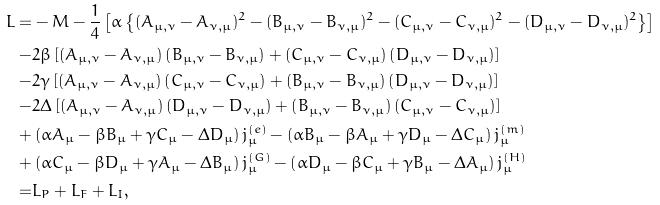<formula> <loc_0><loc_0><loc_500><loc_500>L = & - M - \frac { 1 } { 4 } \left [ \alpha \left \{ ( A _ { \mu , \nu } - A _ { \nu , \mu } ) ^ { 2 } - ( B _ { \mu , \nu } - B _ { \nu , \mu } ) ^ { 2 } - ( C _ { \mu , \nu } - C _ { \nu , \mu } ) ^ { 2 } - ( D _ { \mu , \nu } - D _ { \nu , \mu } ) ^ { 2 } \right \} \right ] \\ - & 2 \beta \left [ \left ( A _ { \mu , \nu } - A _ { \nu , \mu } \right ) \left ( B _ { \mu , \nu } - B _ { \nu , \mu } \right ) + \left ( C _ { \mu , \nu } - C _ { \nu , \mu } \right ) \left ( D _ { \mu , \nu } - D _ { \nu , \mu } \right ) \right ] \\ - & 2 \gamma \left [ \left ( A _ { \mu , \nu } - A _ { \nu , \mu } \right ) \left ( C _ { \mu , \nu } - C _ { \nu , \mu } \right ) + \left ( B _ { \mu , \nu } - B _ { \nu , \mu } \right ) \left ( D _ { \mu , \nu } - D _ { \nu , \mu } \right ) \right ] \\ - & 2 \Delta \left [ \left ( A _ { \mu , \nu } - A _ { \nu , \mu } \right ) \left ( D _ { \mu , \nu } - D _ { \nu , \mu } \right ) + \left ( B _ { \mu , \nu } - B _ { \nu , \mu } \right ) \left ( C _ { \mu , \nu } - C _ { \nu , \mu } \right ) \right ] \\ + & \left ( \alpha A _ { \mu } - \beta B _ { \mu } + \gamma C _ { \mu } - \Delta D _ { \mu } \right ) j _ { \mu } ^ { ( e ) } - \left ( \alpha B _ { \mu } - \beta A _ { \mu } + \gamma D _ { \mu } - \Delta C _ { \mu } \right ) j _ { \mu } ^ { ( m ) } \\ + & \left ( \alpha C _ { \mu } - \beta D _ { \mu } + \gamma A _ { \mu } - \Delta B _ { \mu } \right ) j _ { \mu } ^ { ( G ) } - \left ( \alpha D _ { \mu } - \beta C _ { \mu } + \gamma B _ { \mu } - \Delta A _ { \mu } \right ) j _ { \mu } ^ { ( H ) } \\ = & L _ { P } + L _ { F } + L _ { I } ,</formula> 